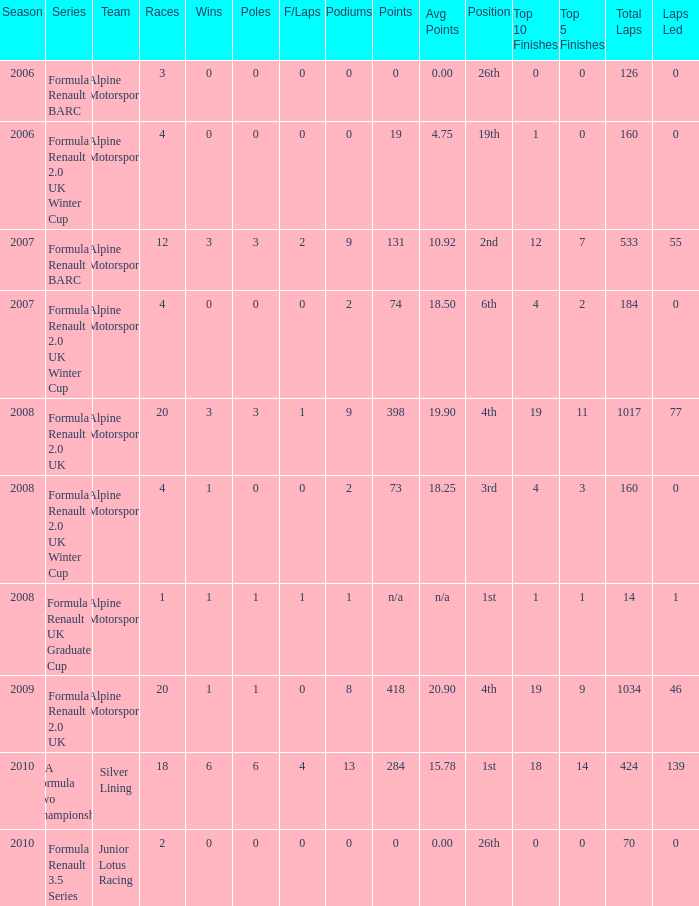Could you help me parse every detail presented in this table? {'header': ['Season', 'Series', 'Team', 'Races', 'Wins', 'Poles', 'F/Laps', 'Podiums', 'Points', 'Avg Points', 'Position', 'Top 10 Finishes', 'Top 5 Finishes', 'Total Laps', 'Laps Led '], 'rows': [['2006', 'Formula Renault BARC', 'Alpine Motorsport', '3', '0', '0', '0', '0', '0', '0.00', '26th', '0', '0', '126', '0'], ['2006', 'Formula Renault 2.0 UK Winter Cup', 'Alpine Motorsport', '4', '0', '0', '0', '0', '19', '4.75', '19th', '1', '0', '160', '0'], ['2007', 'Formula Renault BARC', 'Alpine Motorsport', '12', '3', '3', '2', '9', '131', '10.92', '2nd', '12', '7', '533', '55'], ['2007', 'Formula Renault 2.0 UK Winter Cup', 'Alpine Motorsport', '4', '0', '0', '0', '2', '74', '18.50', '6th', '4', '2', '184', '0'], ['2008', 'Formula Renault 2.0 UK', 'Alpine Motorsport', '20', '3', '3', '1', '9', '398', '19.90', '4th', '19', '11', '1017', '77'], ['2008', 'Formula Renault 2.0 UK Winter Cup', 'Alpine Motorsport', '4', '1', '0', '0', '2', '73', '18.25', '3rd', '4', '3', '160', '0'], ['2008', 'Formula Renault UK Graduate Cup', 'Alpine Motorsport', '1', '1', '1', '1', '1', 'n/a', 'n/a', '1st', '1', '1', '14', '1'], ['2009', 'Formula Renault 2.0 UK', 'Alpine Motorsport', '20', '1', '1', '0', '8', '418', '20.90', '4th', '19', '9', '1034', '46'], ['2010', 'FIA Formula Two Championship', 'Silver Lining', '18', '6', '6', '4', '13', '284', '15.78', '1st', '18', '14', '424', '139'], ['2010', 'Formula Renault 3.5 Series', 'Junior Lotus Racing', '2', '0', '0', '0', '0', '0', '0.00', '26th', '0', '0', '70', '0']]} 0 in 2008? 1.0. 